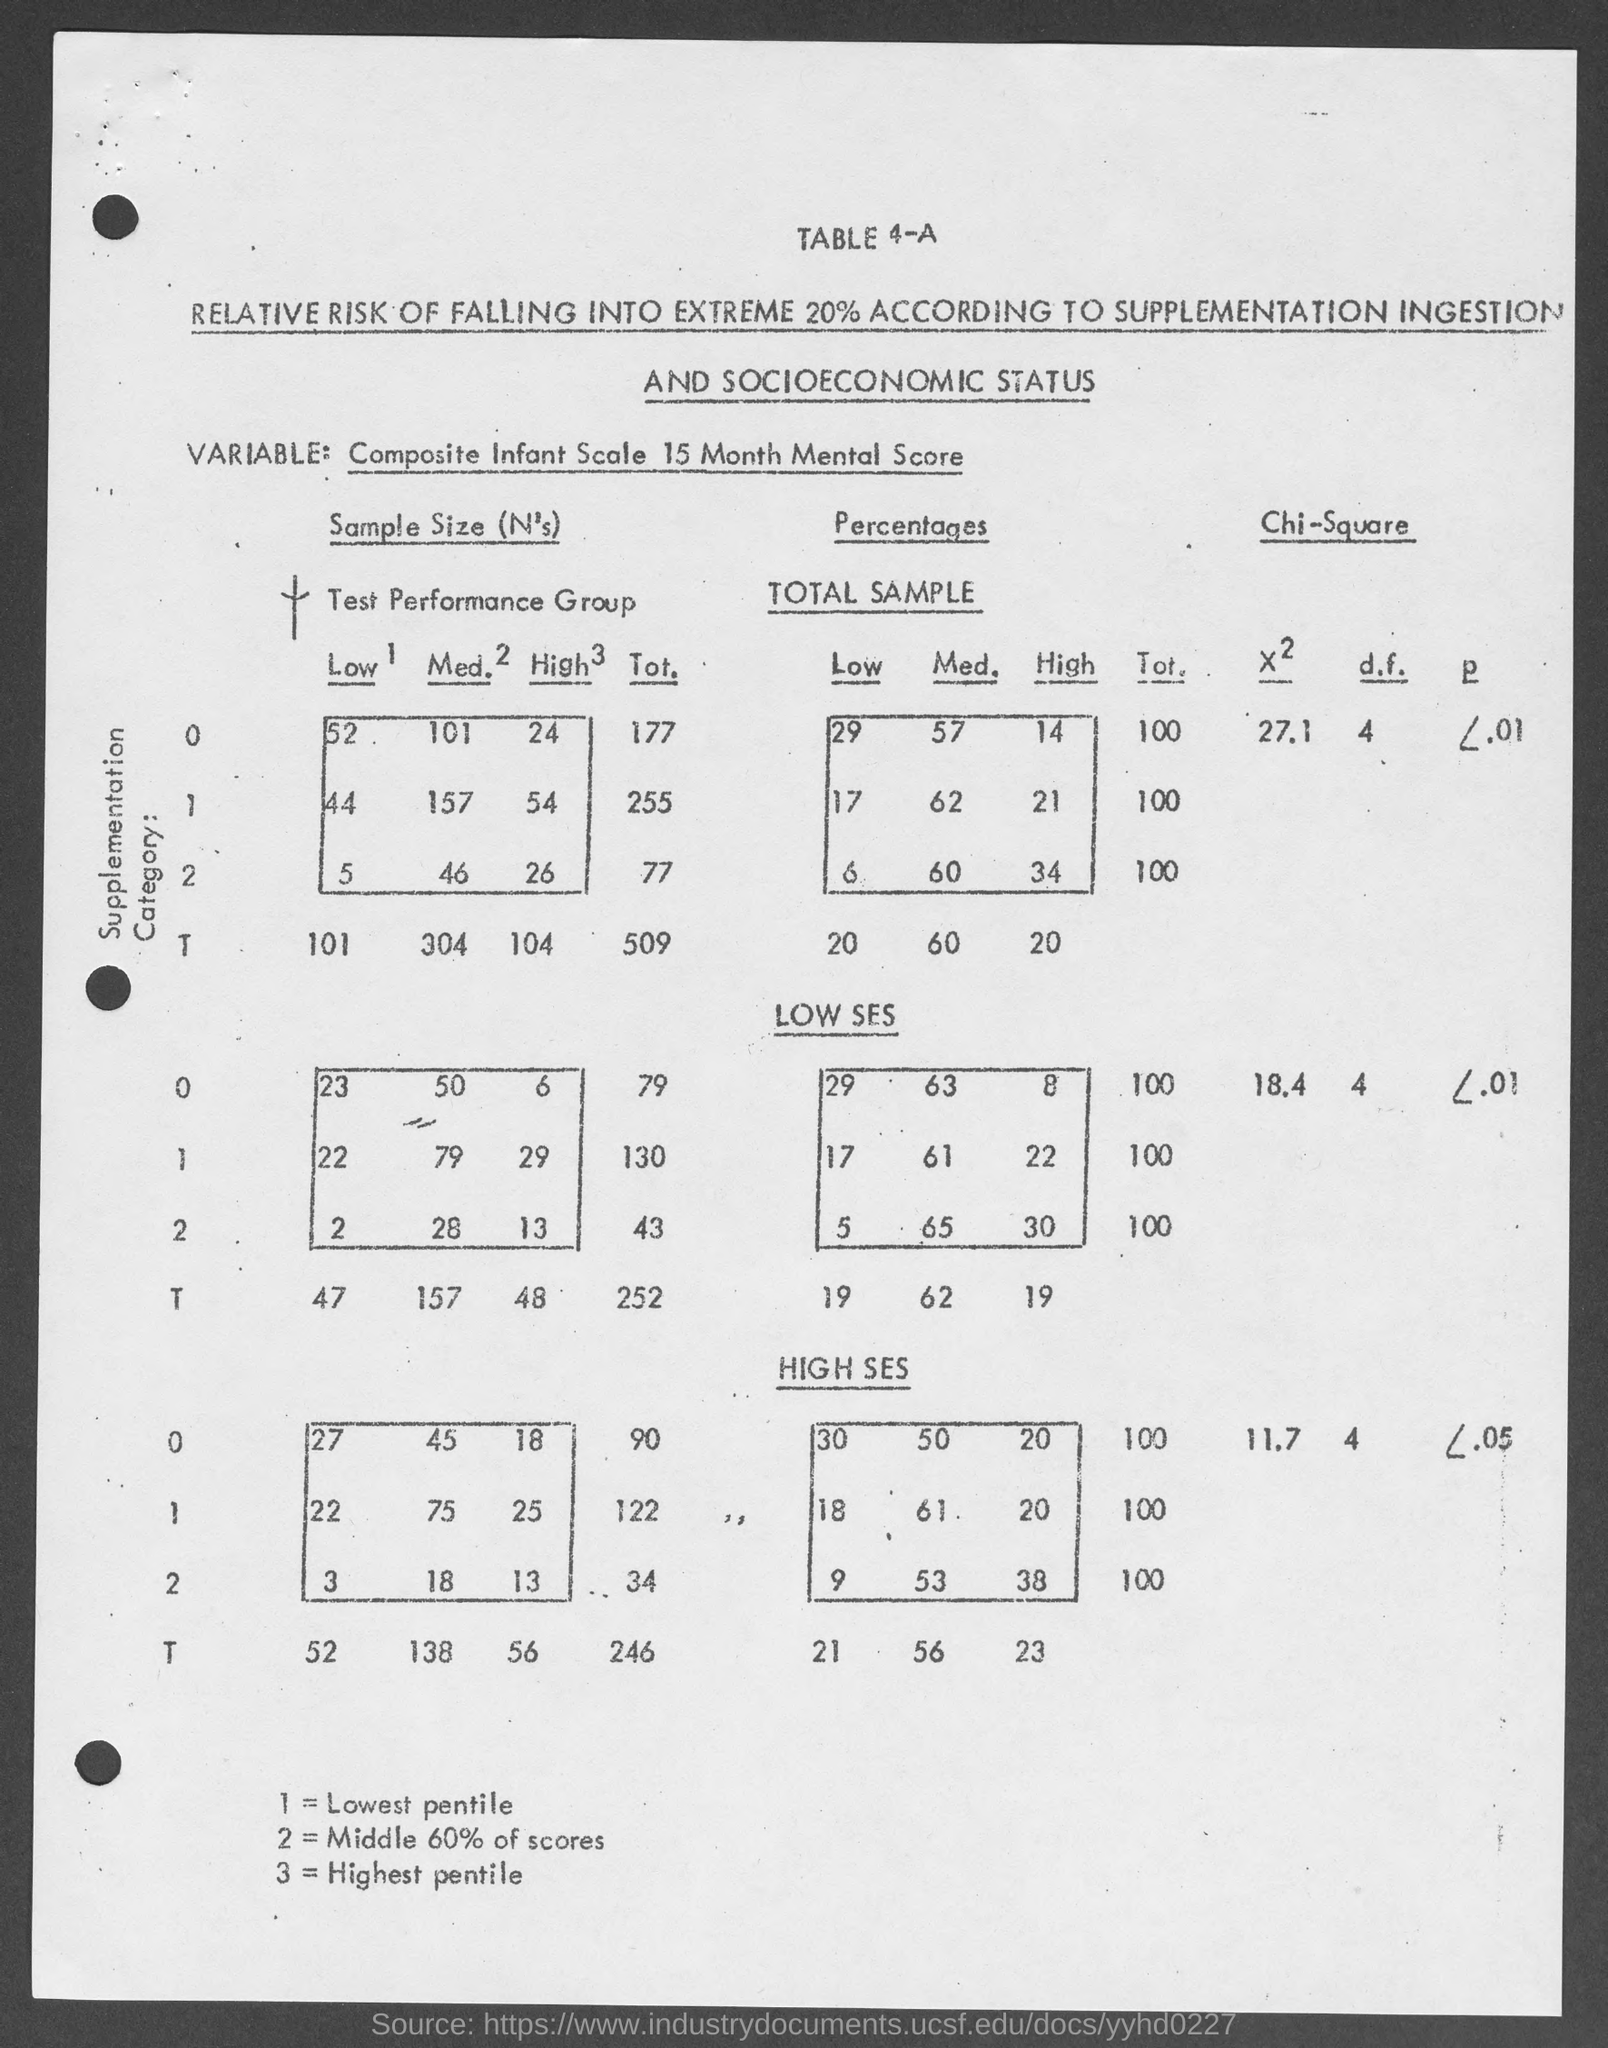What is the Table number ?
Keep it short and to the point. 4-A. What does the number "1" in the document denotes ?
Offer a terse response. Lowest pentile. What does the number "2" in the document denotes ?
Your answer should be compact. Middle 60% of scores. What does the number "3" in the document denotes ?
Keep it short and to the point. Highest pentile. 